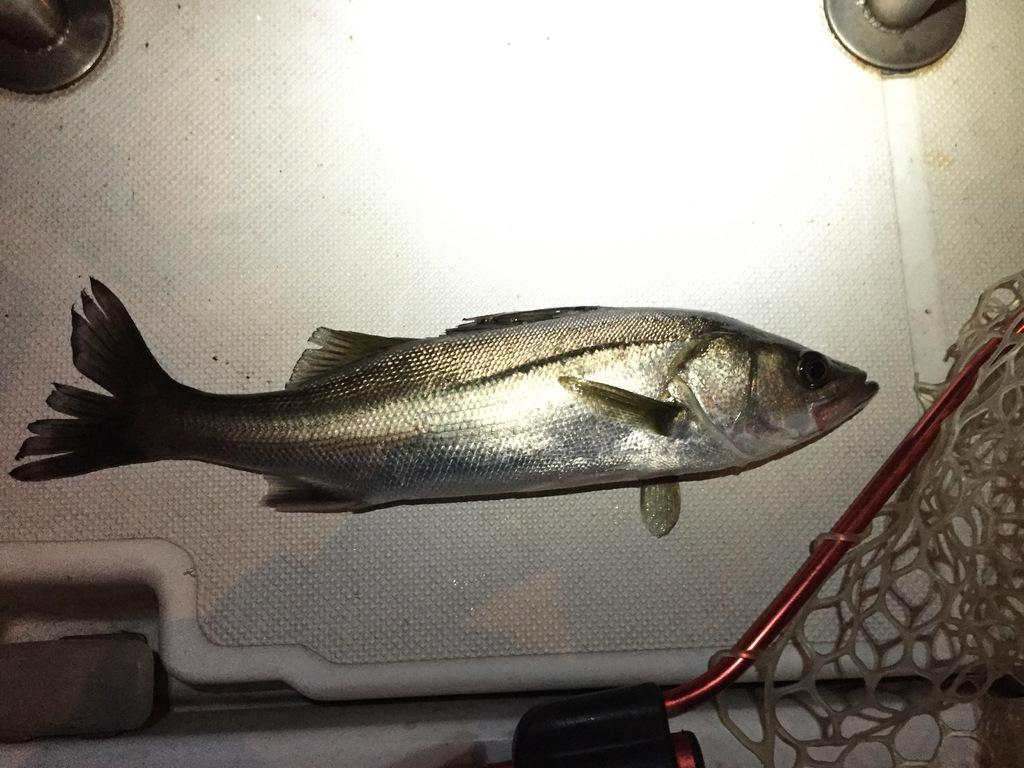What is the main object in the center of the image? There is a table in the center of the image. What is placed on the table? There is a fish and a net on the table. Are there any other objects on the table? Yes, there are other objects on the table. What type of sound can be heard coming from the fish in the image? There is no sound coming from the fish in the image, as it is a still image and not a video or audio recording. 